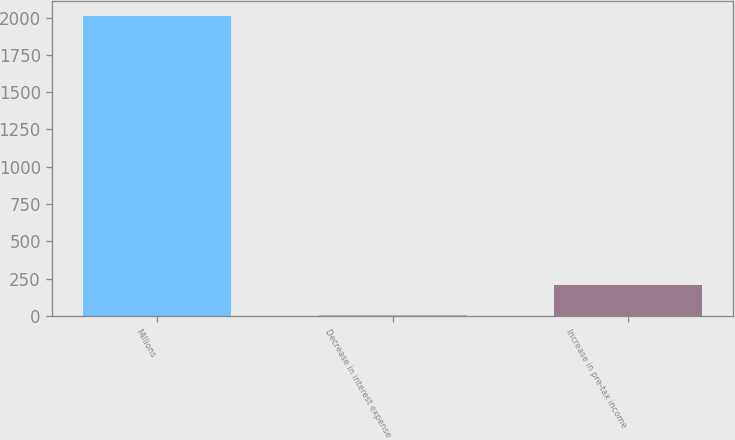<chart> <loc_0><loc_0><loc_500><loc_500><bar_chart><fcel>Millions<fcel>Decrease in interest expense<fcel>Increase in pre-tax income<nl><fcel>2009<fcel>8<fcel>208.1<nl></chart> 